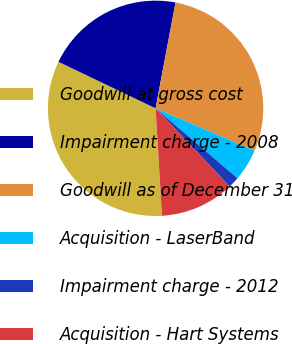<chart> <loc_0><loc_0><loc_500><loc_500><pie_chart><fcel>Goodwill at gross cost<fcel>Impairment charge - 2008<fcel>Goodwill as of December 31<fcel>Acquisition - LaserBand<fcel>Impairment charge - 2012<fcel>Acquisition - Hart Systems<nl><fcel>33.05%<fcel>20.85%<fcel>28.49%<fcel>4.81%<fcel>1.67%<fcel>11.13%<nl></chart> 